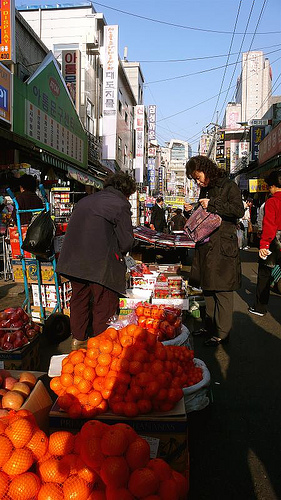Please provide a short description for this region: [0.49, 0.03, 0.67, 0.25]. Light blue is the color of the sky in this region, suggesting a clear day, which is perfect for market activities. 